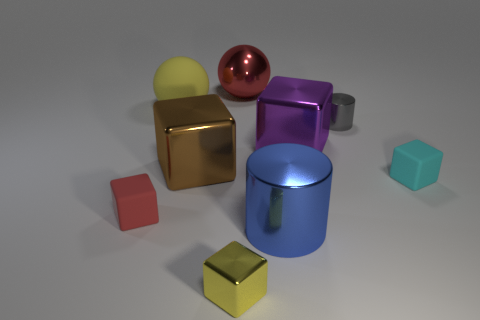Subtract 1 blocks. How many blocks are left? 4 Subtract all red cubes. How many cubes are left? 4 Subtract all cyan cubes. How many cubes are left? 4 Add 1 gray metallic objects. How many objects exist? 10 Subtract all cyan cubes. Subtract all brown balls. How many cubes are left? 4 Subtract all cylinders. How many objects are left? 7 Subtract 1 brown blocks. How many objects are left? 8 Subtract all blue metallic spheres. Subtract all brown objects. How many objects are left? 8 Add 7 big red things. How many big red things are left? 8 Add 3 big cylinders. How many big cylinders exist? 4 